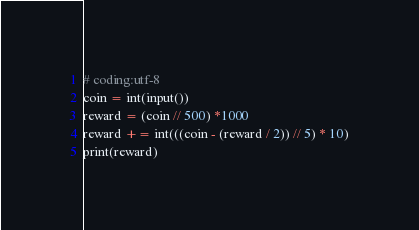Convert code to text. <code><loc_0><loc_0><loc_500><loc_500><_Python_># coding:utf-8
coin = int(input())
reward = (coin // 500) *1000
reward += int(((coin - (reward / 2)) // 5) * 10)
print(reward)</code> 